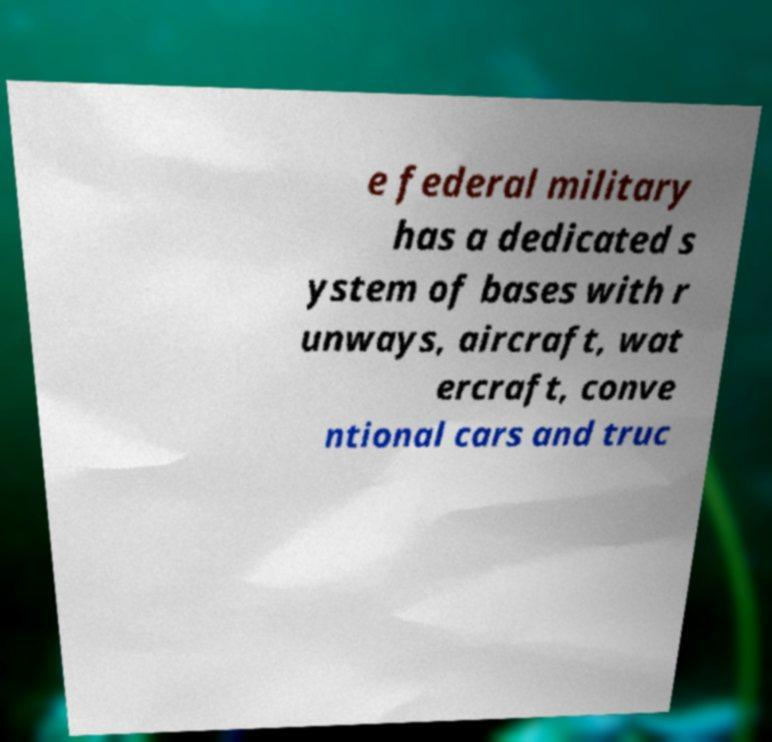Please identify and transcribe the text found in this image. e federal military has a dedicated s ystem of bases with r unways, aircraft, wat ercraft, conve ntional cars and truc 